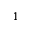Convert formula to latex. <formula><loc_0><loc_0><loc_500><loc_500>^ { 1 }</formula> 